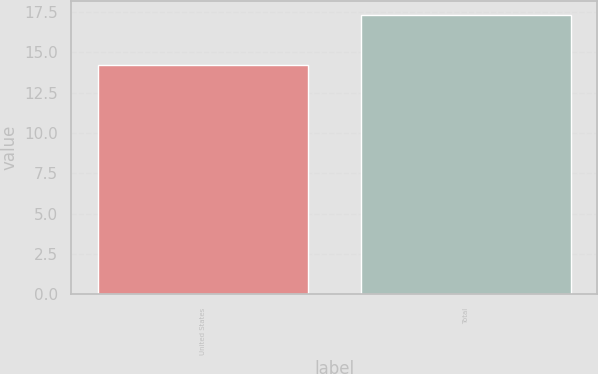Convert chart to OTSL. <chart><loc_0><loc_0><loc_500><loc_500><bar_chart><fcel>United States<fcel>Total<nl><fcel>14.2<fcel>17.3<nl></chart> 